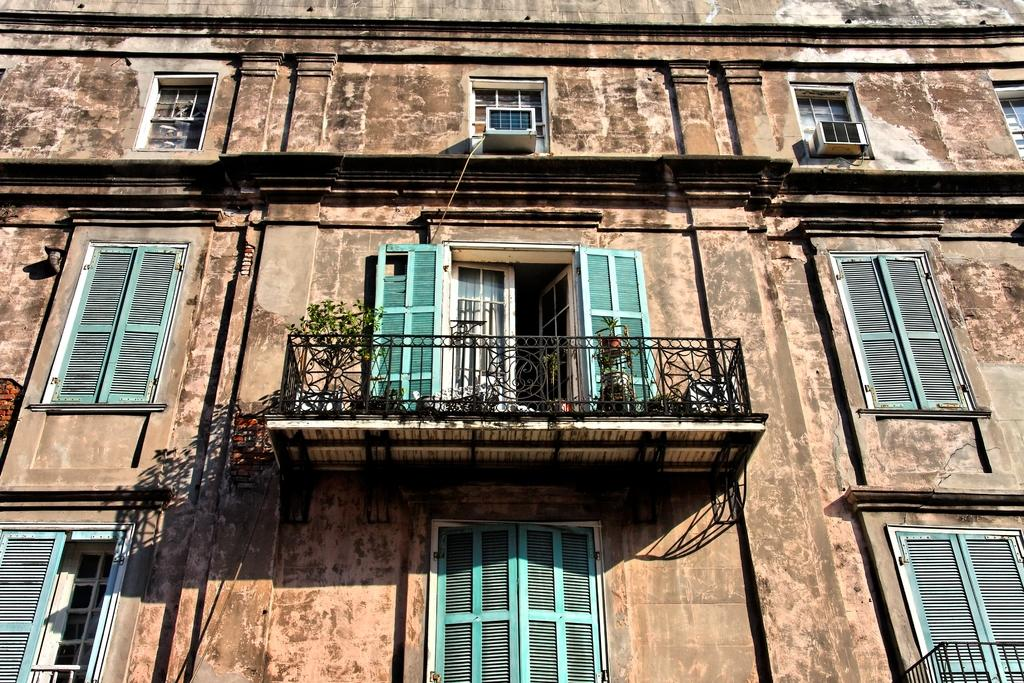What type of structure is visible in the image? There is there a building in the image? What can be seen in the middle of the image? There are plants and a railing in the middle of the image. What feature of the building is visible? Windows are visible in the building. What type of window covering is present in the windows? Window blinds are present in the windows. What type of error can be seen in the image? There is no error present in the image. Can you see any cherries in the image? There are no cherries present in the image. 